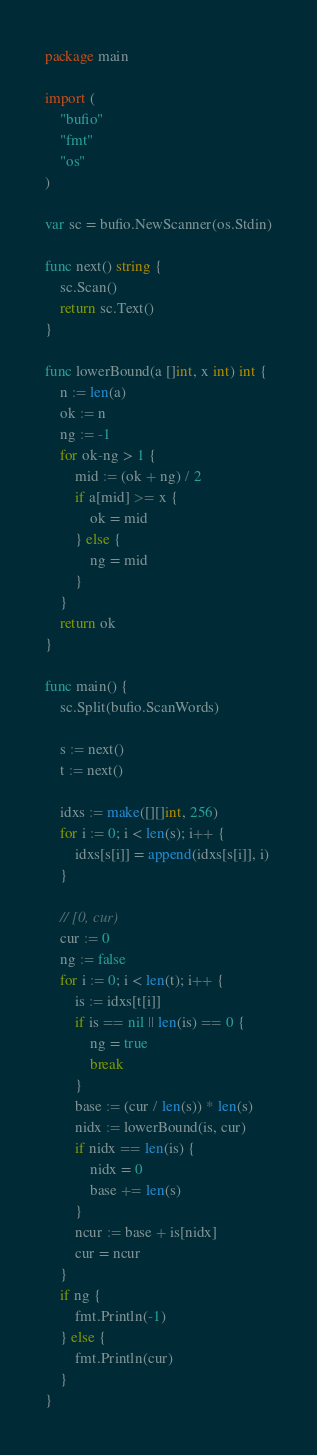<code> <loc_0><loc_0><loc_500><loc_500><_Go_>package main

import (
	"bufio"
	"fmt"
	"os"
)

var sc = bufio.NewScanner(os.Stdin)

func next() string {
	sc.Scan()
	return sc.Text()
}

func lowerBound(a []int, x int) int {
	n := len(a)
	ok := n
	ng := -1
	for ok-ng > 1 {
		mid := (ok + ng) / 2
		if a[mid] >= x {
			ok = mid
		} else {
			ng = mid
		}
	}
	return ok
}

func main() {
	sc.Split(bufio.ScanWords)

	s := next()
	t := next()

	idxs := make([][]int, 256)
	for i := 0; i < len(s); i++ {
		idxs[s[i]] = append(idxs[s[i]], i)
	}

	// [0, cur)
	cur := 0
	ng := false
	for i := 0; i < len(t); i++ {
		is := idxs[t[i]]
		if is == nil || len(is) == 0 {
			ng = true
			break
		}
		base := (cur / len(s)) * len(s)
		nidx := lowerBound(is, cur)
		if nidx == len(is) {
			nidx = 0
			base += len(s)
		}
		ncur := base + is[nidx]
		cur = ncur
	}
	if ng {
		fmt.Println(-1)
	} else {
		fmt.Println(cur)
	}
}
</code> 